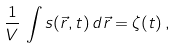Convert formula to latex. <formula><loc_0><loc_0><loc_500><loc_500>\frac { 1 } { V } \, \int s ( \vec { r } , t ) \, d \vec { r } = \zeta ( t ) \, ,</formula> 